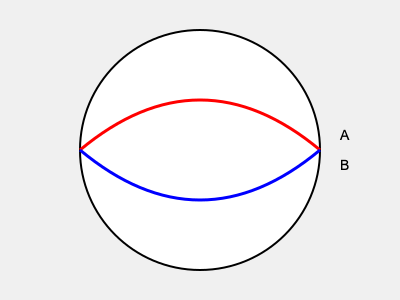In a case involving a cognitive impairment defense, you're presented with the above brain scan image. The red curve (A) represents normal brain activity, while the blue curve (B) represents the defendant's brain activity. What legal strategy would you likely pursue based on this evidence? To interpret this brain scan and determine the appropriate legal strategy, follow these steps:

1. Analyze the image:
   - The red curve (A) represents normal brain activity.
   - The blue curve (B) represents the defendant's brain activity.

2. Compare the curves:
   - The blue curve shows significantly reduced activity compared to the normal curve.
   - This indicates lower brain function or impairment in the defendant.

3. Relate to cognitive impairment:
   - Reduced brain activity often correlates with cognitive impairment.
   - This could affect decision-making, impulse control, or awareness of actions.

4. Consider legal implications:
   - Cognitive impairment can impact criminal responsibility.
   - It may affect the defendant's ability to form intent or understand consequences.

5. Determine strategy:
   - Given the evidence of impairment, pursue a diminished capacity defense.
   - This strategy argues that the defendant's mental state prevented them from fully understanding or controlling their actions.

6. Prepare for court:
   - Engage expert witnesses to explain the brain scan and its implications.
   - Emphasize how the impairment relates to the specific charges and elements of the crime.

7. Consider alternative outcomes:
   - If diminished capacity is successful, it may lead to reduced charges or sentencing.
   - In some jurisdictions, it could support an insanity defense.
Answer: Pursue a diminished capacity defense 